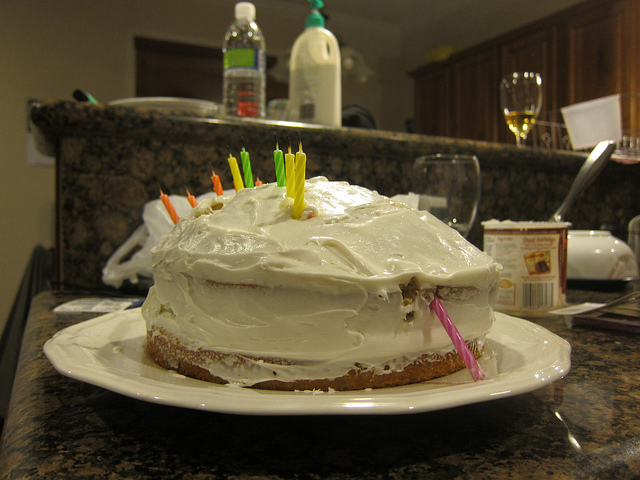Looks like a celebration is going on. What occasions usually involve such cakes? Cakes decorated with candles are commonly associated with birthdays. However, they can also be part of celebrations for achievements, anniversaries, or simply to mark special gatherings with friends and family. 